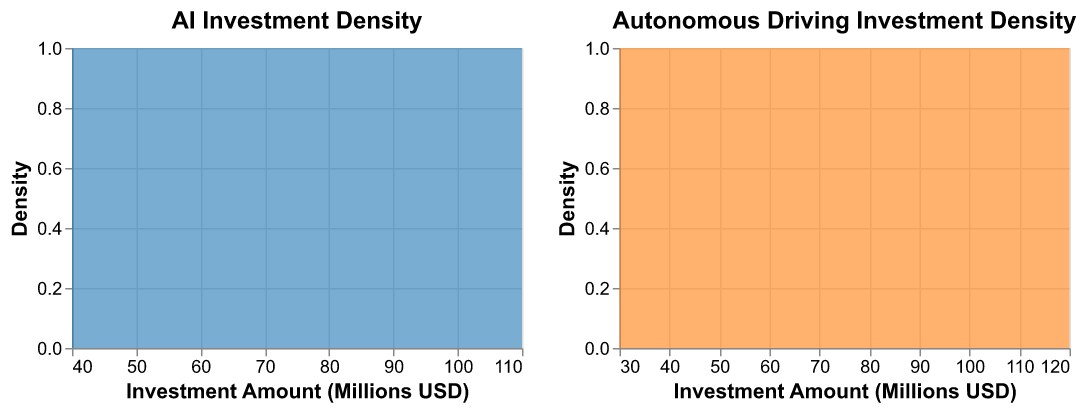What is the main color used for the AI investment density plot? The AI investment density plot is represented by a filled area in a blue shade, as indicated by the color value assigned to it.
Answer: Blue How does the peak density of investment amounts compare between AI and Autonomous Driving subfields? To determine this, one would look at the highest points of both density plots. By comparing the two, we can observe which peak is higher to understand which subfield has a denser distribution of investment amounts.
Answer: Autonomous Driving has a higher peak density Which subfield has a higher median investment amount? By examining the density curves, the x-axis values where the densities are equally split give the median. The plot shows the AI investments more concentrated towards higher values, indicating a higher median investment amount compared to Autonomous Driving.
Answer: AI What is the range of investments for the AI subfield? The AI density plot extends roughly from 40 million USD to over 110 million USD, giving the range of investments.
Answer: 40 to 110 million USD Between 60 and 80 million USD, which subfield has a higher density of investments? By observing the density plots in the range of 60 to 80 million USD, the density curve for AI subfield is higher than that for Autonomous Driving, indicating more frequent investments in AI within this range.
Answer: AI Is there any overlap in the investment amounts for AI and Autonomous Driving? Looking at the x-axis where both AI and Autonomous Driving density plots are present, we can see an overlap in the range from approximately 40 to 110 million USD.
Answer: Yes How does the spread of investment amounts in Autonomous Driving compare to AI? The density plot for Autonomous Driving shows a wider spread of investment amounts compared to AI, indicating a greater variance in investments. Specifically, it ranges roughly from 30 million USD to 120 million USD.
Answer: Wider At what investment amount do both subfields have similar densities? By identifying the points where the density curves intersect, we see that around 70 million USD, both the density curves for AI and Autonomous Driving are similar.
Answer: 70 million USD What can you infer about the frequency of large investments (above 100 million USD) in both subfields? The density curves indicate that large investments above 100 million USD are more common in Autonomous Driving, as shown by the density peak extending further in this subfield compared to AI.
Answer: More common in Autonomous Driving 